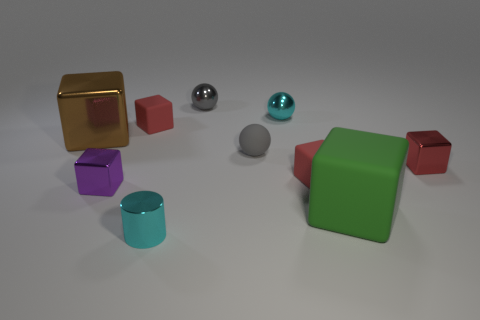Subtract all cyan balls. How many red blocks are left? 3 Subtract 3 cubes. How many cubes are left? 3 Subtract all purple blocks. How many blocks are left? 5 Subtract all green blocks. How many blocks are left? 5 Subtract all blue blocks. Subtract all blue spheres. How many blocks are left? 6 Subtract all blocks. How many objects are left? 4 Add 2 tiny gray matte balls. How many tiny gray matte balls exist? 3 Subtract 0 gray cylinders. How many objects are left? 10 Subtract all metallic cylinders. Subtract all metal cylinders. How many objects are left? 8 Add 5 tiny gray spheres. How many tiny gray spheres are left? 7 